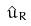Convert formula to latex. <formula><loc_0><loc_0><loc_500><loc_500>\hat { u } _ { R }</formula> 